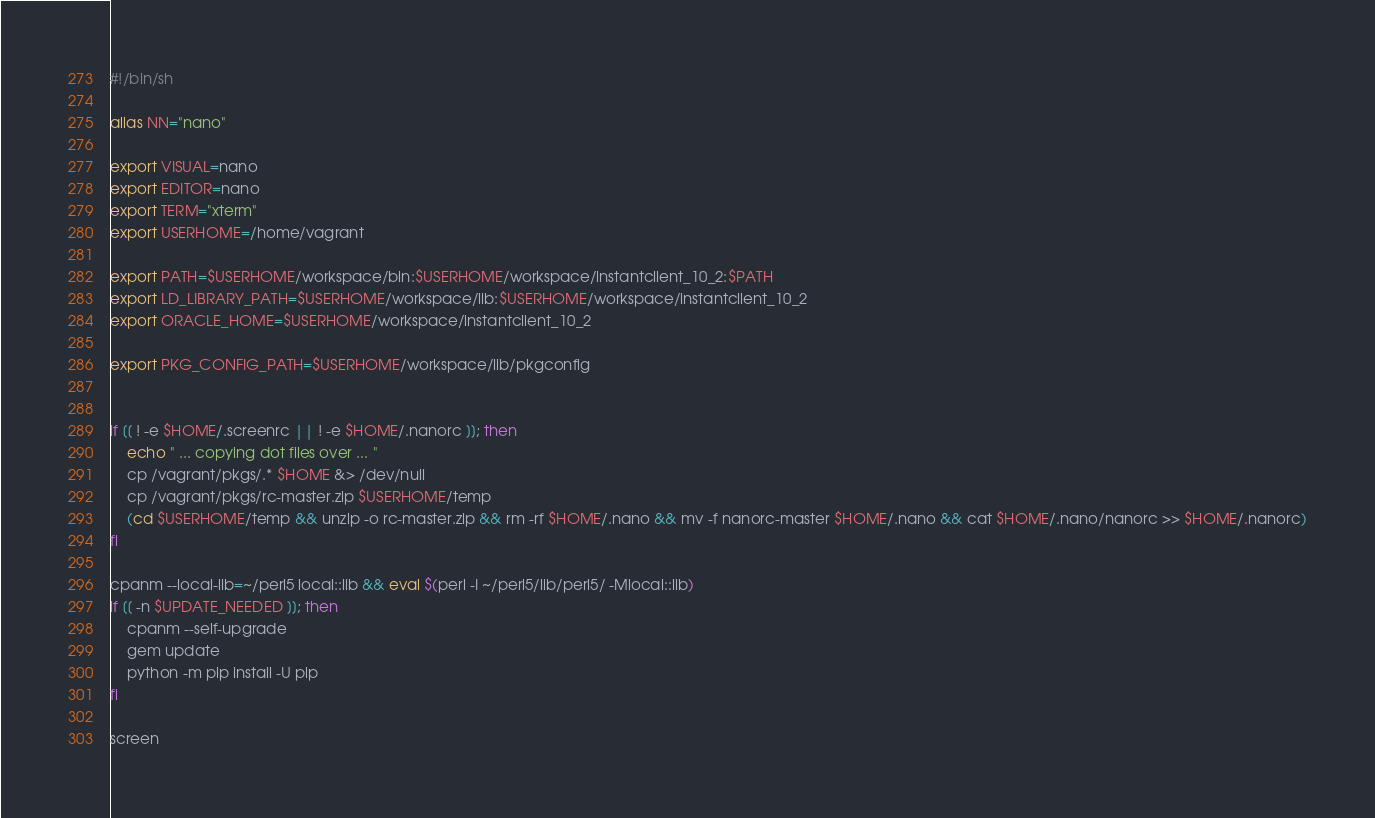<code> <loc_0><loc_0><loc_500><loc_500><_Bash_>#!/bin/sh

alias NN="nano"

export VISUAL=nano
export EDITOR=nano
export TERM="xterm"
export USERHOME=/home/vagrant

export PATH=$USERHOME/workspace/bin:$USERHOME/workspace/instantclient_10_2:$PATH
export LD_LIBRARY_PATH=$USERHOME/workspace/lib:$USERHOME/workspace/instantclient_10_2
export ORACLE_HOME=$USERHOME/workspace/instantclient_10_2

export PKG_CONFIG_PATH=$USERHOME/workspace/lib/pkgconfig


if [[ ! -e $HOME/.screenrc || ! -e $HOME/.nanorc ]]; then
    echo " ... copying dot files over ... "
    cp /vagrant/pkgs/.* $HOME &> /dev/null
    cp /vagrant/pkgs/rc-master.zip $USERHOME/temp
    (cd $USERHOME/temp && unzip -o rc-master.zip && rm -rf $HOME/.nano && mv -f nanorc-master $HOME/.nano && cat $HOME/.nano/nanorc >> $HOME/.nanorc)
fi

cpanm --local-lib=~/perl5 local::lib && eval $(perl -I ~/perl5/lib/perl5/ -Mlocal::lib)
if [[ -n $UPDATE_NEEDED ]]; then 
    cpanm --self-upgrade
    gem update
    python -m pip install -U pip
fi

screen
</code> 